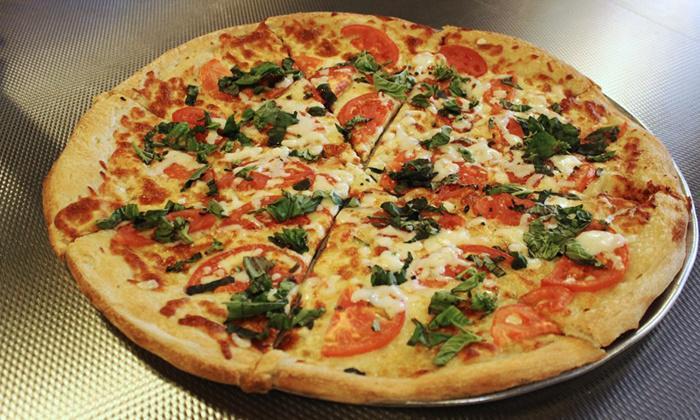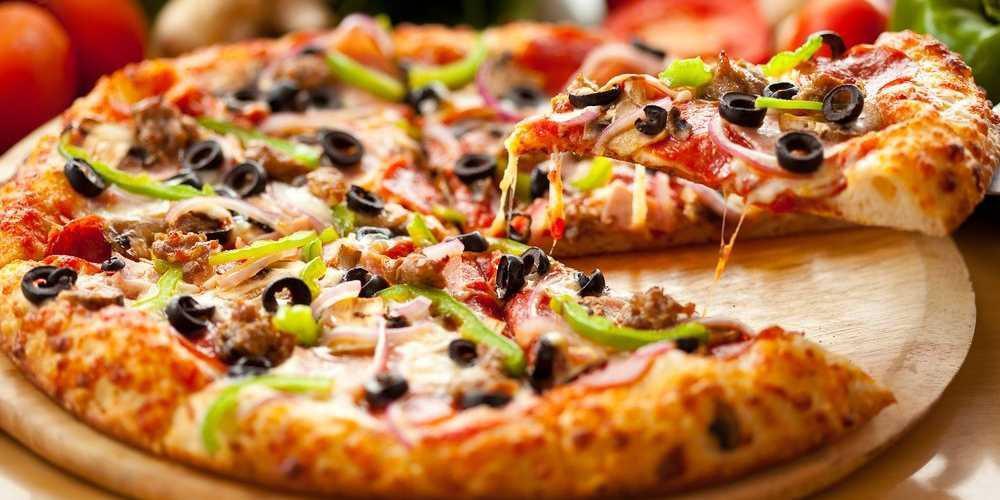The first image is the image on the left, the second image is the image on the right. For the images shown, is this caption "One of the pizzas has a single slice lifted with cheese stretching from it, and the other pizza is sliced but has all slices in place." true? Answer yes or no. Yes. The first image is the image on the left, the second image is the image on the right. Given the left and right images, does the statement "there is a pizza with a slice being lifted with green peppers on it" hold true? Answer yes or no. Yes. 